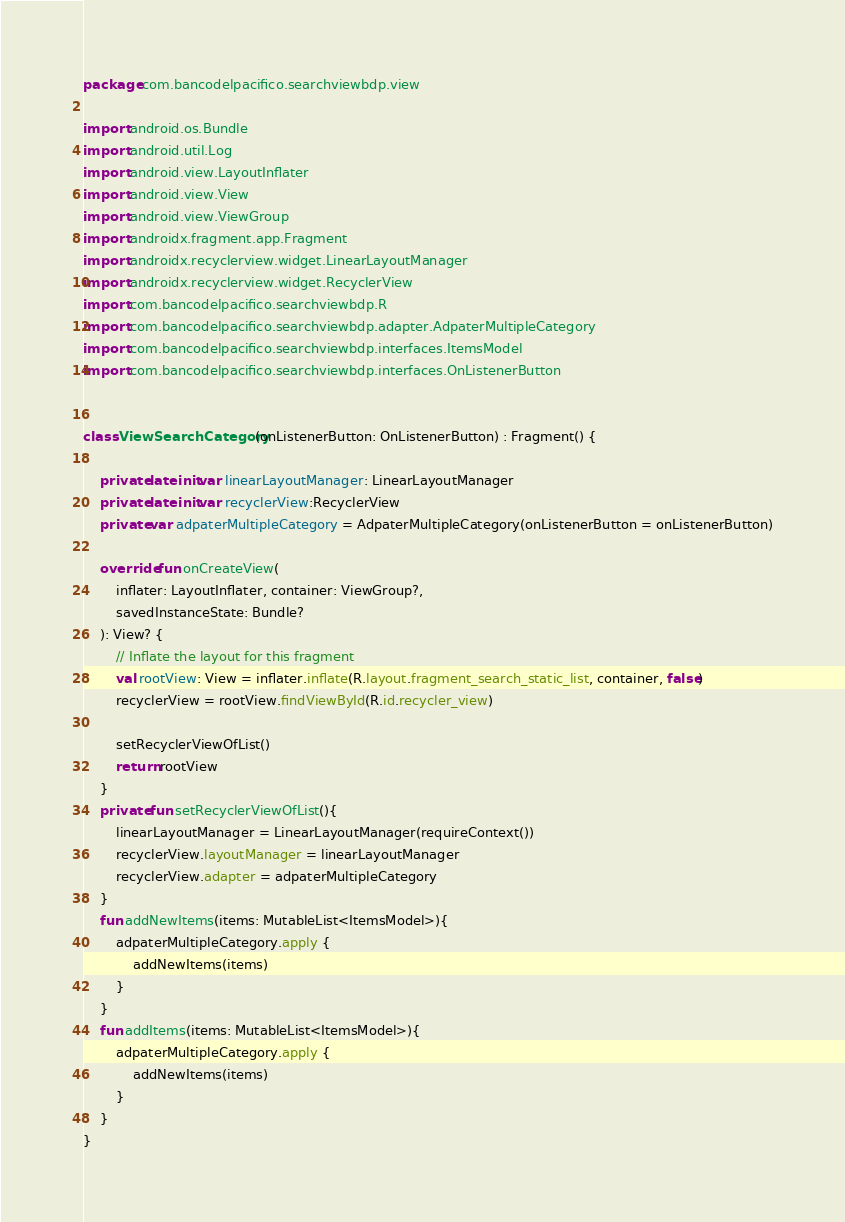<code> <loc_0><loc_0><loc_500><loc_500><_Kotlin_>package com.bancodelpacifico.searchviewbdp.view

import android.os.Bundle
import android.util.Log
import android.view.LayoutInflater
import android.view.View
import android.view.ViewGroup
import androidx.fragment.app.Fragment
import androidx.recyclerview.widget.LinearLayoutManager
import androidx.recyclerview.widget.RecyclerView
import com.bancodelpacifico.searchviewbdp.R
import com.bancodelpacifico.searchviewbdp.adapter.AdpaterMultipleCategory
import com.bancodelpacifico.searchviewbdp.interfaces.ItemsModel
import com.bancodelpacifico.searchviewbdp.interfaces.OnListenerButton


class ViewSearchCategory(onListenerButton: OnListenerButton) : Fragment() {

    private lateinit var linearLayoutManager: LinearLayoutManager
    private lateinit var recyclerView:RecyclerView
    private var adpaterMultipleCategory = AdpaterMultipleCategory(onListenerButton = onListenerButton)

    override fun onCreateView(
        inflater: LayoutInflater, container: ViewGroup?,
        savedInstanceState: Bundle?
    ): View? {
        // Inflate the layout for this fragment
        val rootView: View = inflater.inflate(R.layout.fragment_search_static_list, container, false)
        recyclerView = rootView.findViewById(R.id.recycler_view)

        setRecyclerViewOfList()
        return rootView
    }
    private fun setRecyclerViewOfList(){
        linearLayoutManager = LinearLayoutManager(requireContext())
        recyclerView.layoutManager = linearLayoutManager
        recyclerView.adapter = adpaterMultipleCategory
    }
    fun addNewItems(items: MutableList<ItemsModel>){
        adpaterMultipleCategory.apply {
            addNewItems(items)
        }
    }
    fun addItems(items: MutableList<ItemsModel>){
        adpaterMultipleCategory.apply {
            addNewItems(items)
        }
    }
}

</code> 